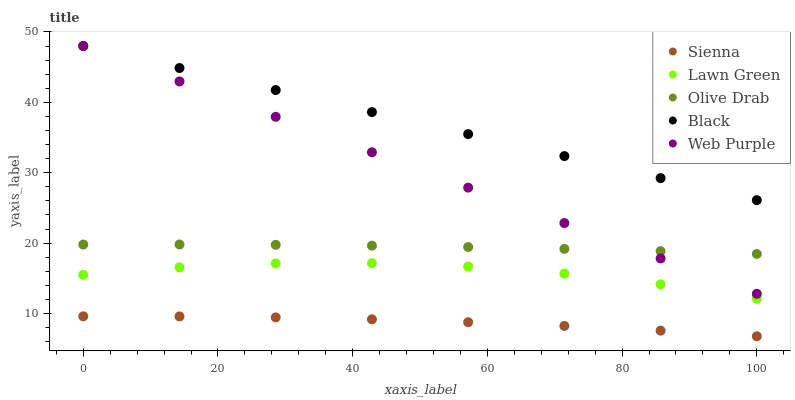Does Sienna have the minimum area under the curve?
Answer yes or no. Yes. Does Black have the maximum area under the curve?
Answer yes or no. Yes. Does Lawn Green have the minimum area under the curve?
Answer yes or no. No. Does Lawn Green have the maximum area under the curve?
Answer yes or no. No. Is Web Purple the smoothest?
Answer yes or no. Yes. Is Lawn Green the roughest?
Answer yes or no. Yes. Is Lawn Green the smoothest?
Answer yes or no. No. Is Web Purple the roughest?
Answer yes or no. No. Does Sienna have the lowest value?
Answer yes or no. Yes. Does Lawn Green have the lowest value?
Answer yes or no. No. Does Black have the highest value?
Answer yes or no. Yes. Does Lawn Green have the highest value?
Answer yes or no. No. Is Sienna less than Olive Drab?
Answer yes or no. Yes. Is Olive Drab greater than Lawn Green?
Answer yes or no. Yes. Does Olive Drab intersect Web Purple?
Answer yes or no. Yes. Is Olive Drab less than Web Purple?
Answer yes or no. No. Is Olive Drab greater than Web Purple?
Answer yes or no. No. Does Sienna intersect Olive Drab?
Answer yes or no. No. 